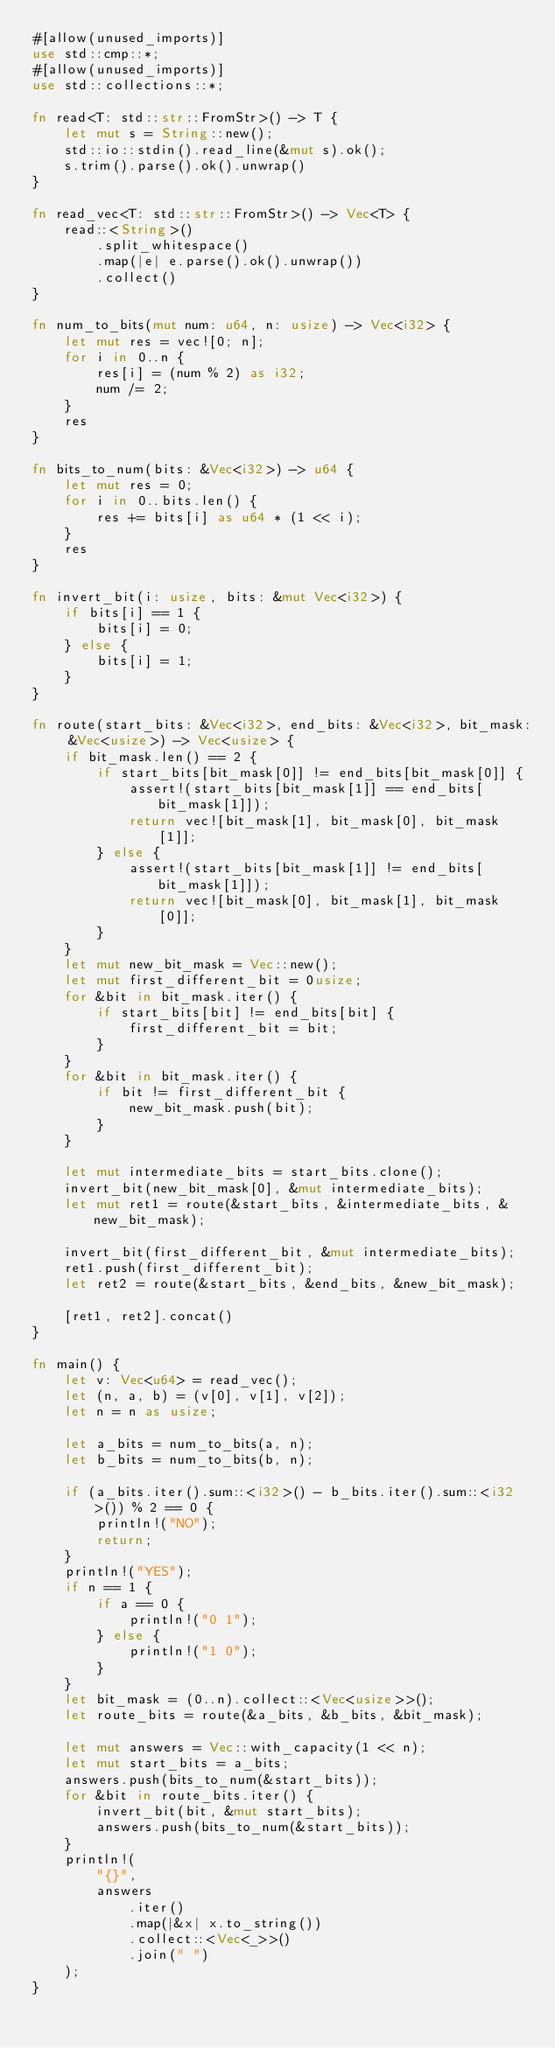Convert code to text. <code><loc_0><loc_0><loc_500><loc_500><_Rust_>#[allow(unused_imports)]
use std::cmp::*;
#[allow(unused_imports)]
use std::collections::*;

fn read<T: std::str::FromStr>() -> T {
    let mut s = String::new();
    std::io::stdin().read_line(&mut s).ok();
    s.trim().parse().ok().unwrap()
}

fn read_vec<T: std::str::FromStr>() -> Vec<T> {
    read::<String>()
        .split_whitespace()
        .map(|e| e.parse().ok().unwrap())
        .collect()
}

fn num_to_bits(mut num: u64, n: usize) -> Vec<i32> {
    let mut res = vec![0; n];
    for i in 0..n {
        res[i] = (num % 2) as i32;
        num /= 2;
    }
    res
}

fn bits_to_num(bits: &Vec<i32>) -> u64 {
    let mut res = 0;
    for i in 0..bits.len() {
        res += bits[i] as u64 * (1 << i);
    }
    res
}

fn invert_bit(i: usize, bits: &mut Vec<i32>) {
    if bits[i] == 1 {
        bits[i] = 0;
    } else {
        bits[i] = 1;
    }
}

fn route(start_bits: &Vec<i32>, end_bits: &Vec<i32>, bit_mask: &Vec<usize>) -> Vec<usize> {
    if bit_mask.len() == 2 {
        if start_bits[bit_mask[0]] != end_bits[bit_mask[0]] {
            assert!(start_bits[bit_mask[1]] == end_bits[bit_mask[1]]);
            return vec![bit_mask[1], bit_mask[0], bit_mask[1]];
        } else {
            assert!(start_bits[bit_mask[1]] != end_bits[bit_mask[1]]);
            return vec![bit_mask[0], bit_mask[1], bit_mask[0]];
        }
    }
    let mut new_bit_mask = Vec::new();
    let mut first_different_bit = 0usize;
    for &bit in bit_mask.iter() {
        if start_bits[bit] != end_bits[bit] {
            first_different_bit = bit;
        }
    }
    for &bit in bit_mask.iter() {
        if bit != first_different_bit {
            new_bit_mask.push(bit);
        }
    }

    let mut intermediate_bits = start_bits.clone();
    invert_bit(new_bit_mask[0], &mut intermediate_bits);
    let mut ret1 = route(&start_bits, &intermediate_bits, &new_bit_mask);

    invert_bit(first_different_bit, &mut intermediate_bits);
    ret1.push(first_different_bit);
    let ret2 = route(&start_bits, &end_bits, &new_bit_mask);

    [ret1, ret2].concat()
}

fn main() {
    let v: Vec<u64> = read_vec();
    let (n, a, b) = (v[0], v[1], v[2]);
    let n = n as usize;

    let a_bits = num_to_bits(a, n);
    let b_bits = num_to_bits(b, n);

    if (a_bits.iter().sum::<i32>() - b_bits.iter().sum::<i32>()) % 2 == 0 {
        println!("NO");
        return;
    }
    println!("YES");
    if n == 1 {
        if a == 0 {
            println!("0 1");
        } else {
            println!("1 0");
        }
    }
    let bit_mask = (0..n).collect::<Vec<usize>>();
    let route_bits = route(&a_bits, &b_bits, &bit_mask);

    let mut answers = Vec::with_capacity(1 << n);
    let mut start_bits = a_bits;
    answers.push(bits_to_num(&start_bits));
    for &bit in route_bits.iter() {
        invert_bit(bit, &mut start_bits);
        answers.push(bits_to_num(&start_bits));
    }
    println!(
        "{}",
        answers
            .iter()
            .map(|&x| x.to_string())
            .collect::<Vec<_>>()
            .join(" ")
    );
}
</code> 